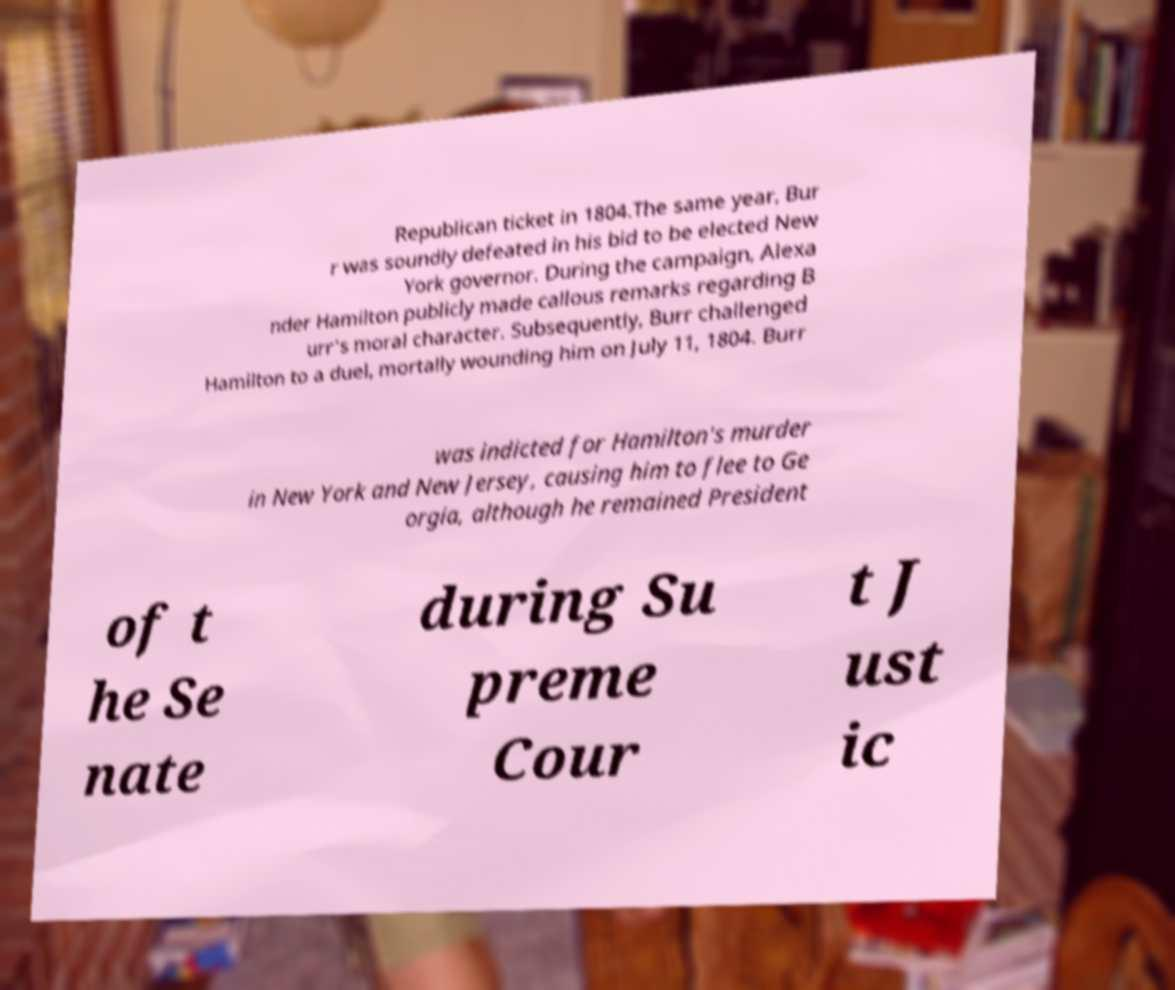Could you assist in decoding the text presented in this image and type it out clearly? Republican ticket in 1804.The same year, Bur r was soundly defeated in his bid to be elected New York governor. During the campaign, Alexa nder Hamilton publicly made callous remarks regarding B urr's moral character. Subsequently, Burr challenged Hamilton to a duel, mortally wounding him on July 11, 1804. Burr was indicted for Hamilton's murder in New York and New Jersey, causing him to flee to Ge orgia, although he remained President of t he Se nate during Su preme Cour t J ust ic 